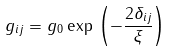Convert formula to latex. <formula><loc_0><loc_0><loc_500><loc_500>g _ { i j } = g _ { 0 } \exp \, \left ( - \frac { 2 \delta _ { i j } } { \xi } \right )</formula> 